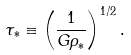<formula> <loc_0><loc_0><loc_500><loc_500>\tau _ { * } \equiv \left ( \frac { 1 } { G \rho _ { * } } \right ) ^ { 1 / 2 } .</formula> 